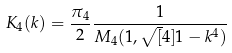Convert formula to latex. <formula><loc_0><loc_0><loc_500><loc_500>K _ { 4 } ( k ) = \frac { \pi _ { 4 } } { 2 } \frac { 1 } { M _ { 4 } ( 1 , \sqrt { [ } 4 ] { 1 - k ^ { 4 } } ) }</formula> 